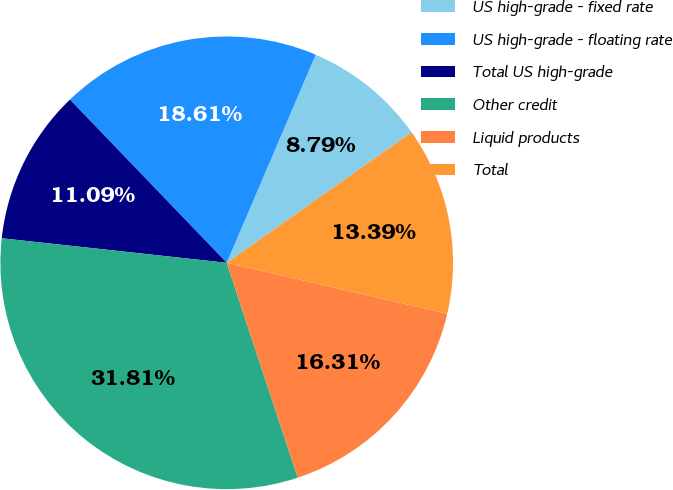Convert chart to OTSL. <chart><loc_0><loc_0><loc_500><loc_500><pie_chart><fcel>US high-grade - fixed rate<fcel>US high-grade - floating rate<fcel>Total US high-grade<fcel>Other credit<fcel>Liquid products<fcel>Total<nl><fcel>8.79%<fcel>18.61%<fcel>11.09%<fcel>31.81%<fcel>16.31%<fcel>13.39%<nl></chart> 